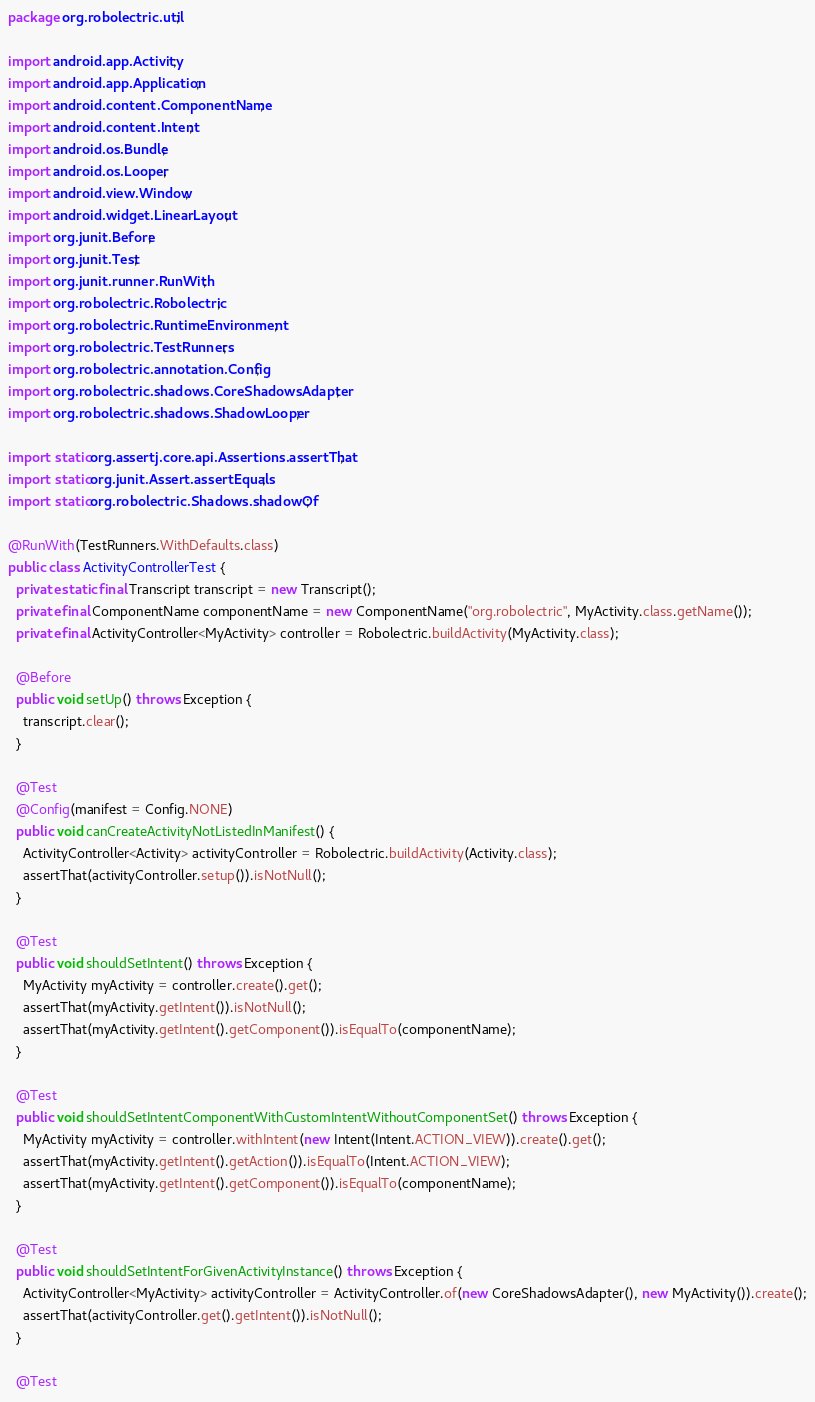<code> <loc_0><loc_0><loc_500><loc_500><_Java_>package org.robolectric.util;

import android.app.Activity;
import android.app.Application;
import android.content.ComponentName;
import android.content.Intent;
import android.os.Bundle;
import android.os.Looper;
import android.view.Window;
import android.widget.LinearLayout;
import org.junit.Before;
import org.junit.Test;
import org.junit.runner.RunWith;
import org.robolectric.Robolectric;
import org.robolectric.RuntimeEnvironment;
import org.robolectric.TestRunners;
import org.robolectric.annotation.Config;
import org.robolectric.shadows.CoreShadowsAdapter;
import org.robolectric.shadows.ShadowLooper;

import static org.assertj.core.api.Assertions.assertThat;
import static org.junit.Assert.assertEquals;
import static org.robolectric.Shadows.shadowOf;

@RunWith(TestRunners.WithDefaults.class)
public class ActivityControllerTest {
  private static final Transcript transcript = new Transcript();
  private final ComponentName componentName = new ComponentName("org.robolectric", MyActivity.class.getName());
  private final ActivityController<MyActivity> controller = Robolectric.buildActivity(MyActivity.class);

  @Before
  public void setUp() throws Exception {
    transcript.clear();
  }

  @Test
  @Config(manifest = Config.NONE)
  public void canCreateActivityNotListedInManifest() {
    ActivityController<Activity> activityController = Robolectric.buildActivity(Activity.class);
    assertThat(activityController.setup()).isNotNull();
  }

  @Test
  public void shouldSetIntent() throws Exception {
    MyActivity myActivity = controller.create().get();
    assertThat(myActivity.getIntent()).isNotNull();
    assertThat(myActivity.getIntent().getComponent()).isEqualTo(componentName);
  }

  @Test
  public void shouldSetIntentComponentWithCustomIntentWithoutComponentSet() throws Exception {
    MyActivity myActivity = controller.withIntent(new Intent(Intent.ACTION_VIEW)).create().get();
    assertThat(myActivity.getIntent().getAction()).isEqualTo(Intent.ACTION_VIEW);
    assertThat(myActivity.getIntent().getComponent()).isEqualTo(componentName);
  }

  @Test
  public void shouldSetIntentForGivenActivityInstance() throws Exception {
    ActivityController<MyActivity> activityController = ActivityController.of(new CoreShadowsAdapter(), new MyActivity()).create();
    assertThat(activityController.get().getIntent()).isNotNull();
  }

  @Test</code> 